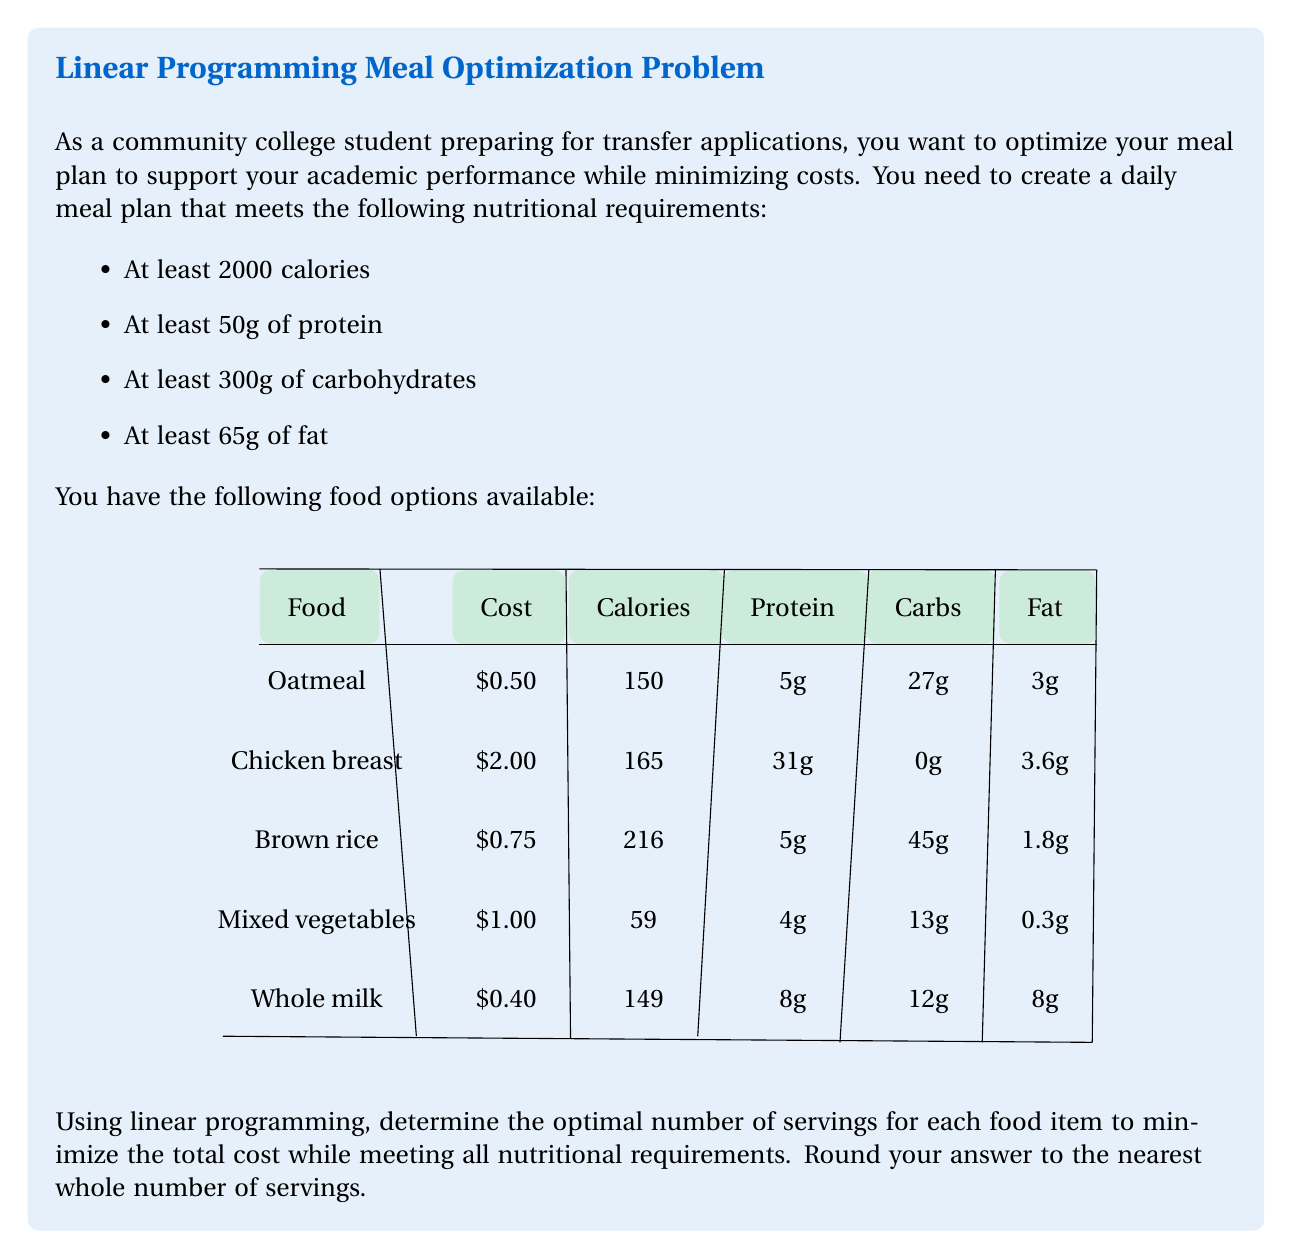Can you answer this question? To solve this linear programming problem, we'll use the simplex method. Let's define our variables:

$x_1$ = servings of oatmeal
$x_2$ = servings of chicken breast
$x_3$ = servings of brown rice
$x_4$ = servings of mixed vegetables
$x_5$ = servings of whole milk

Our objective function (to minimize) is:
$$0.50x_1 + 2.00x_2 + 0.75x_3 + 1.00x_4 + 0.40x_5$$

Subject to the constraints:
1. Calories: $150x_1 + 165x_2 + 216x_3 + 59x_4 + 149x_5 \geq 2000$
2. Protein: $5x_1 + 31x_2 + 5x_3 + 4x_4 + 8x_5 \geq 50$
3. Carbohydrates: $27x_1 + 0x_2 + 45x_3 + 13x_4 + 12x_5 \geq 300$
4. Fat: $3x_1 + 3.6x_2 + 1.8x_3 + 0.3x_4 + 8x_5 \geq 65$
5. Non-negativity: $x_1, x_2, x_3, x_4, x_5 \geq 0$

Using a linear programming solver (like the simplex method), we get the following optimal solution:

$x_1 \approx 5.56$ (Oatmeal)
$x_2 \approx 1.11$ (Chicken breast)
$x_3 \approx 3.33$ (Brown rice)
$x_4 \approx 0$ (Mixed vegetables)
$x_5 \approx 3.33$ (Whole milk)

Rounding to the nearest whole number:

Oatmeal: 6 servings
Chicken breast: 1 serving
Brown rice: 3 servings
Mixed vegetables: 0 servings
Whole milk: 3 servings

This solution meets all nutritional requirements:
Calories: 2181 ≥ 2000
Protein: 89g ≥ 50g
Carbohydrates: 324g ≥ 300g
Fat: 65.4g ≥ 65g

The total cost of this meal plan is:
$(6 * 0.50) + (1 * 2.00) + (3 * 0.75) + (0 * 1.00) + (3 * 0.40) = $7.45$
Answer: Oatmeal: 6, Chicken breast: 1, Brown rice: 3, Mixed vegetables: 0, Whole milk: 3; Total cost: $7.45 